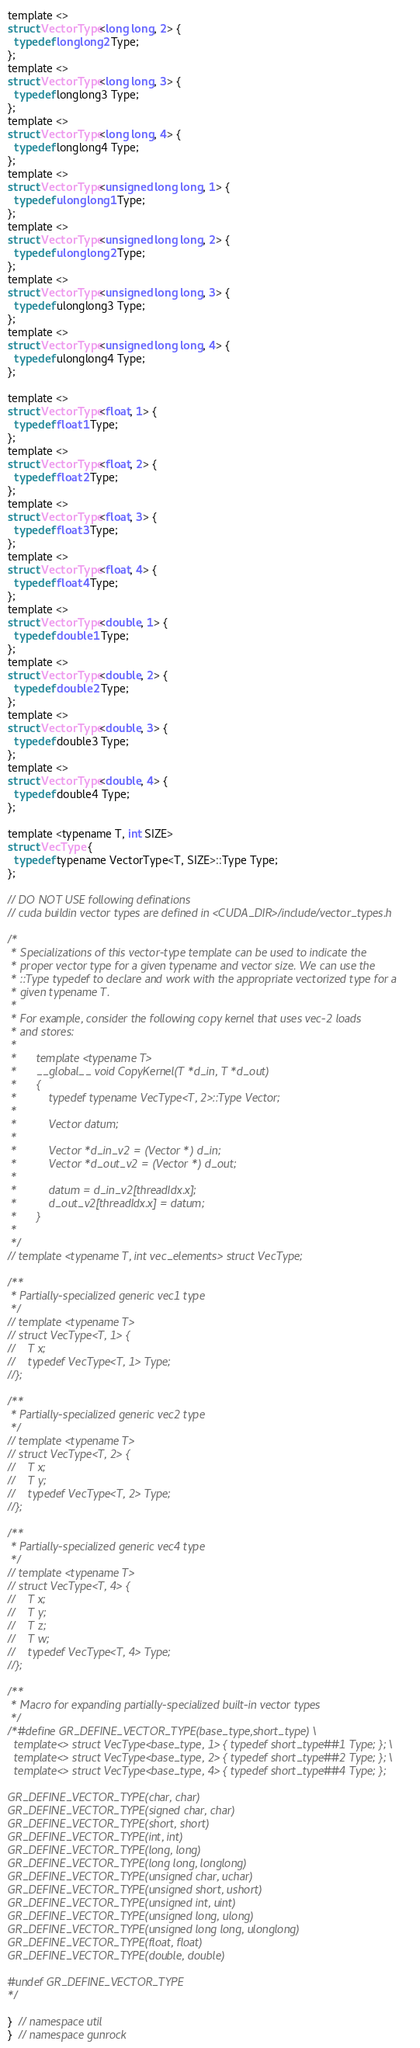<code> <loc_0><loc_0><loc_500><loc_500><_Cuda_>template <>
struct VectorType<long long, 2> {
  typedef longlong2 Type;
};
template <>
struct VectorType<long long, 3> {
  typedef longlong3 Type;
};
template <>
struct VectorType<long long, 4> {
  typedef longlong4 Type;
};
template <>
struct VectorType<unsigned long long, 1> {
  typedef ulonglong1 Type;
};
template <>
struct VectorType<unsigned long long, 2> {
  typedef ulonglong2 Type;
};
template <>
struct VectorType<unsigned long long, 3> {
  typedef ulonglong3 Type;
};
template <>
struct VectorType<unsigned long long, 4> {
  typedef ulonglong4 Type;
};

template <>
struct VectorType<float, 1> {
  typedef float1 Type;
};
template <>
struct VectorType<float, 2> {
  typedef float2 Type;
};
template <>
struct VectorType<float, 3> {
  typedef float3 Type;
};
template <>
struct VectorType<float, 4> {
  typedef float4 Type;
};
template <>
struct VectorType<double, 1> {
  typedef double1 Type;
};
template <>
struct VectorType<double, 2> {
  typedef double2 Type;
};
template <>
struct VectorType<double, 3> {
  typedef double3 Type;
};
template <>
struct VectorType<double, 4> {
  typedef double4 Type;
};

template <typename T, int SIZE>
struct VecType {
  typedef typename VectorType<T, SIZE>::Type Type;
};

// DO NOT USE following definations
// cuda buildin vector types are defined in <CUDA_DIR>/include/vector_types.h

/*
 * Specializations of this vector-type template can be used to indicate the
 * proper vector type for a given typename and vector size. We can use the
 * ::Type typedef to declare and work with the appropriate vectorized type for a
 * given typename T.
 *
 * For example, consider the following copy kernel that uses vec-2 loads
 * and stores:
 *
 *      template <typename T>
 *      __global__ void CopyKernel(T *d_in, T *d_out)
 *      {
 *          typedef typename VecType<T, 2>::Type Vector;
 *
 *          Vector datum;
 *
 *          Vector *d_in_v2 = (Vector *) d_in;
 *          Vector *d_out_v2 = (Vector *) d_out;
 *
 *          datum = d_in_v2[threadIdx.x];
 *          d_out_v2[threadIdx.x] = datum;
 *      }
 *
 */
// template <typename T, int vec_elements> struct VecType;

/**
 * Partially-specialized generic vec1 type
 */
// template <typename T>
// struct VecType<T, 1> {
//    T x;
//    typedef VecType<T, 1> Type;
//};

/**
 * Partially-specialized generic vec2 type
 */
// template <typename T>
// struct VecType<T, 2> {
//    T x;
//    T y;
//    typedef VecType<T, 2> Type;
//};

/**
 * Partially-specialized generic vec4 type
 */
// template <typename T>
// struct VecType<T, 4> {
//    T x;
//    T y;
//    T z;
//    T w;
//    typedef VecType<T, 4> Type;
//};

/**
 * Macro for expanding partially-specialized built-in vector types
 */
/*#define GR_DEFINE_VECTOR_TYPE(base_type,short_type) \
  template<> struct VecType<base_type, 1> { typedef short_type##1 Type; }; \
  template<> struct VecType<base_type, 2> { typedef short_type##2 Type; }; \
  template<> struct VecType<base_type, 4> { typedef short_type##4 Type; };

GR_DEFINE_VECTOR_TYPE(char, char)
GR_DEFINE_VECTOR_TYPE(signed char, char)
GR_DEFINE_VECTOR_TYPE(short, short)
GR_DEFINE_VECTOR_TYPE(int, int)
GR_DEFINE_VECTOR_TYPE(long, long)
GR_DEFINE_VECTOR_TYPE(long long, longlong)
GR_DEFINE_VECTOR_TYPE(unsigned char, uchar)
GR_DEFINE_VECTOR_TYPE(unsigned short, ushort)
GR_DEFINE_VECTOR_TYPE(unsigned int, uint)
GR_DEFINE_VECTOR_TYPE(unsigned long, ulong)
GR_DEFINE_VECTOR_TYPE(unsigned long long, ulonglong)
GR_DEFINE_VECTOR_TYPE(float, float)
GR_DEFINE_VECTOR_TYPE(double, double)

#undef GR_DEFINE_VECTOR_TYPE
*/

}  // namespace util
}  // namespace gunrock
</code> 